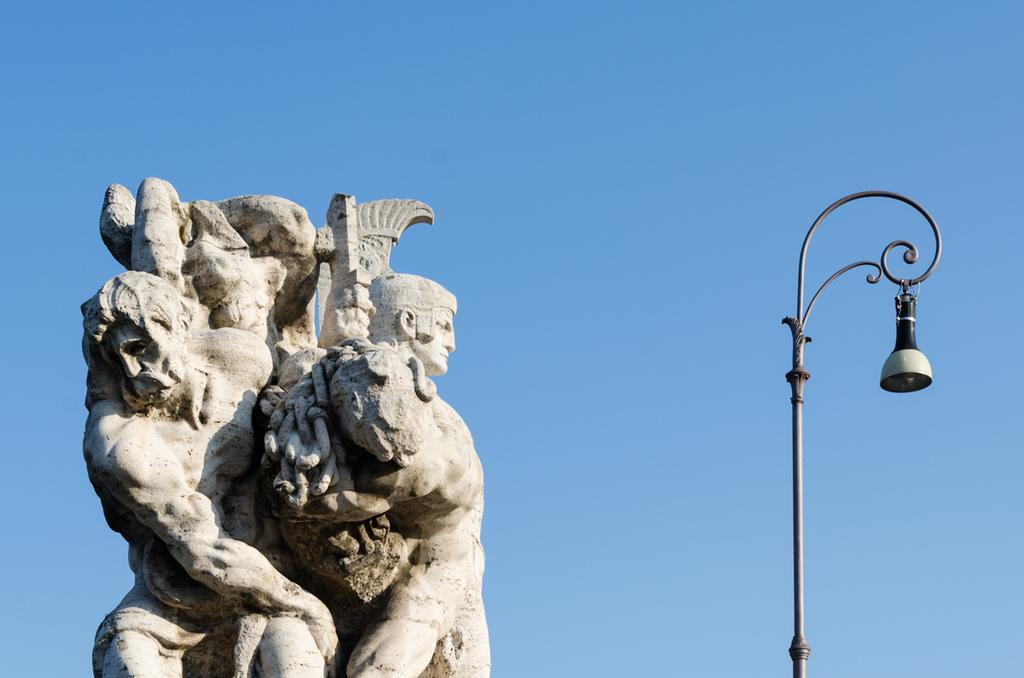What is the main subject in the image? There is a sculpture in the image. What else can be seen in the image besides the sculpture? There is a street light in the image. How would you describe the color of the sky in the image? The sky is blue in the image. What type of lock is used to secure the government building in the image? There is no government building or lock present in the image; it features a sculpture and a street light. 